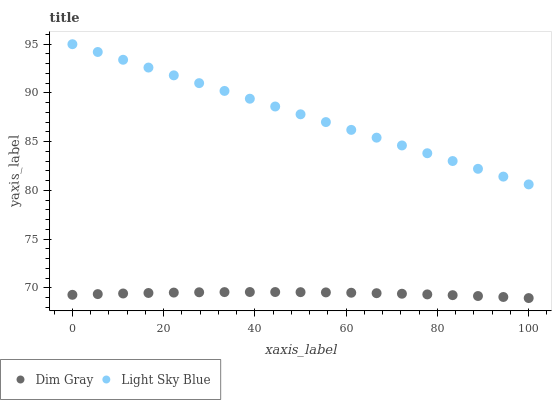Does Dim Gray have the minimum area under the curve?
Answer yes or no. Yes. Does Light Sky Blue have the maximum area under the curve?
Answer yes or no. Yes. Does Light Sky Blue have the minimum area under the curve?
Answer yes or no. No. Is Light Sky Blue the smoothest?
Answer yes or no. Yes. Is Dim Gray the roughest?
Answer yes or no. Yes. Is Light Sky Blue the roughest?
Answer yes or no. No. Does Dim Gray have the lowest value?
Answer yes or no. Yes. Does Light Sky Blue have the lowest value?
Answer yes or no. No. Does Light Sky Blue have the highest value?
Answer yes or no. Yes. Is Dim Gray less than Light Sky Blue?
Answer yes or no. Yes. Is Light Sky Blue greater than Dim Gray?
Answer yes or no. Yes. Does Dim Gray intersect Light Sky Blue?
Answer yes or no. No. 